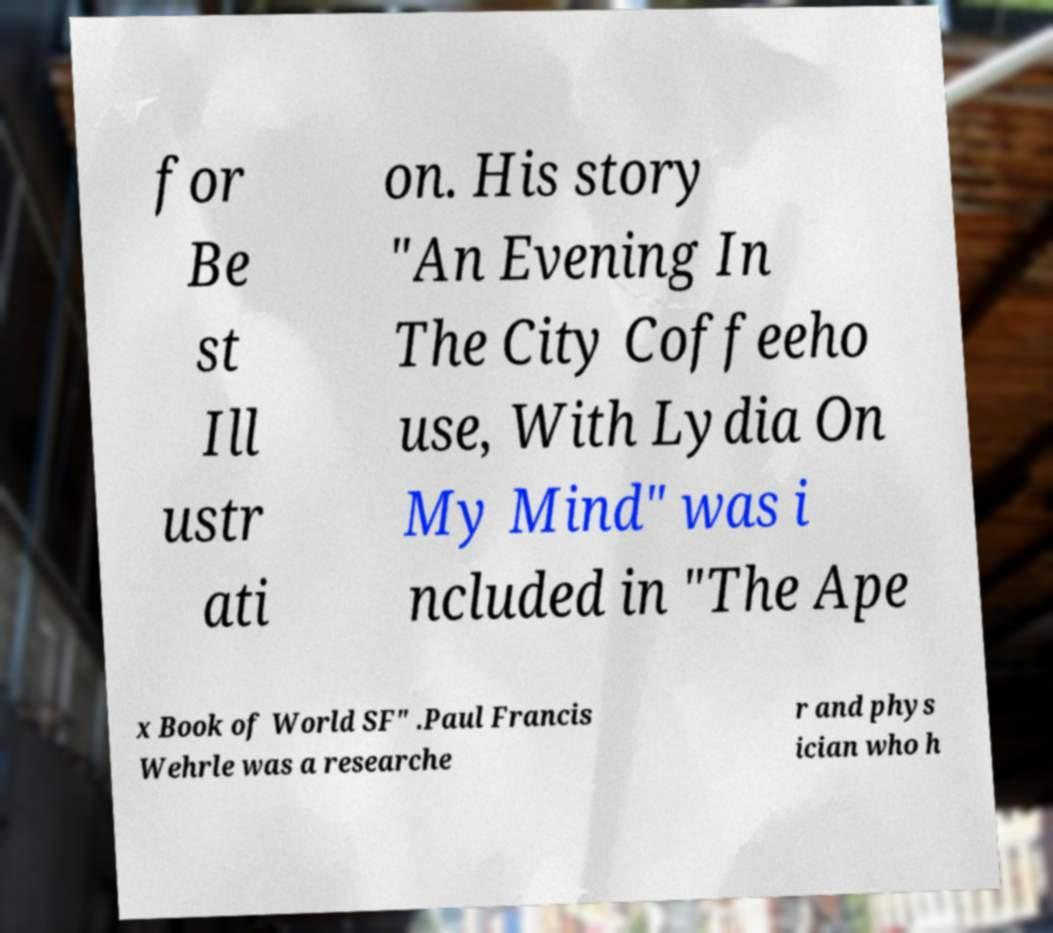For documentation purposes, I need the text within this image transcribed. Could you provide that? for Be st Ill ustr ati on. His story "An Evening In The City Coffeeho use, With Lydia On My Mind" was i ncluded in "The Ape x Book of World SF" .Paul Francis Wehrle was a researche r and phys ician who h 